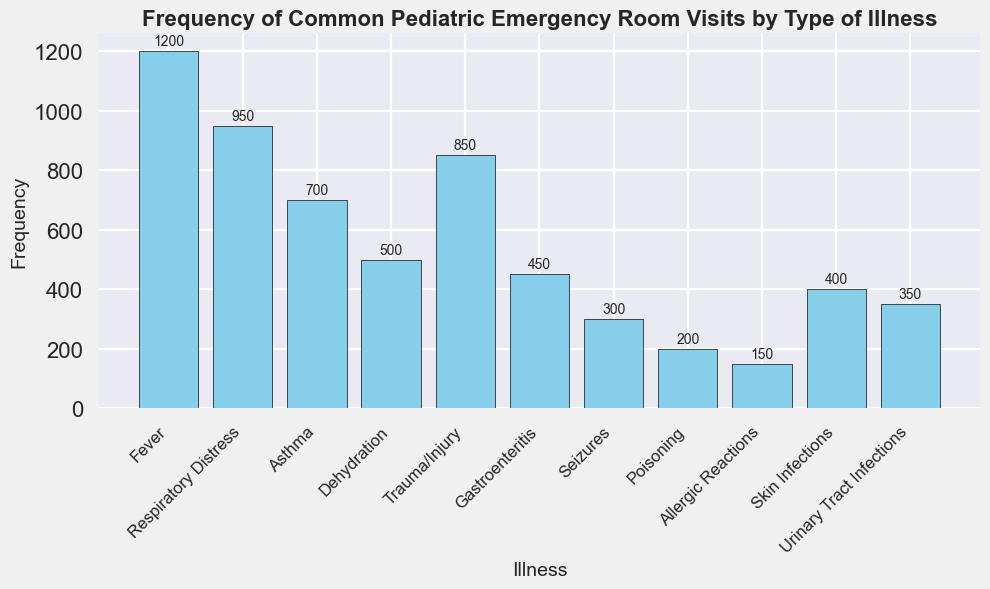Which illness has the highest frequency of emergency room visits? The tallest bar represents the illness with the highest frequency. The bar for "Fever" is the tallest with a value of 1200.
Answer: Fever Which illness has the lowest frequency of emergency room visits? The shortest bar represents the illness with the lowest frequency. The bar for "Allergic Reactions" is the shortest with a value of 150.
Answer: Allergic Reactions What is the total frequency of emergency room visits for Respiratory Distress and Trauma/Injury? The frequency for Respiratory Distress is 950, and for Trauma/Injury, it is 850. Summing them up gives: 950 + 850.
Answer: 1800 How many more visits are there for Asthma compared to Seizures? The frequency for Asthma is 700, and for Seizures, it is 300. Subtracting Seizures from Asthma gives: 700 - 300.
Answer: 400 Which illnesses have a frequency greater than 800? By examining the bars with heights greater than 800, we find "Fever" with 1200, "Respiratory Distress" with 950, and "Trauma/Injury" with 850.
Answer: Fever, Respiratory Distress, Trauma/Injury Rank the illnesses related to infections from most to least frequent. The illnesses related to infections are "Skin Infections" (400) and "Urinary Tract Infections" (350). Rank them from highest to lowest: "Skin Infections" (400), "Urinary Tract Infections" (350).
Answer: Skin Infections, Urinary Tract Infections What is the average frequency for Dehydration, Gastroenteritis, and Poisoning? The frequencies are Dehydration (500), Gastroenteritis (450), and Poisoning (200). Summing these frequencies is 500 + 450 + 200 = 1150. Dividing by 3 gives the average: 1150 / 3 ≈ 383.33.
Answer: 383.33 How much higher is the frequency of Fever compared to Allergic Reactions? The frequency for Fever is 1200, and for Allergic Reactions, it is 150. Subtracting Allergic Reactions from Fever gives: 1200 - 150.
Answer: 1050 What is the median frequency of all the illnesses? Listing frequencies in ascending order: 150, 200, 300, 350, 400, 450, 500, 700, 850, 950, 1200. The median is the value at the middle position in this ordered list, which is 450 (Gastroenteritis).
Answer: 450 